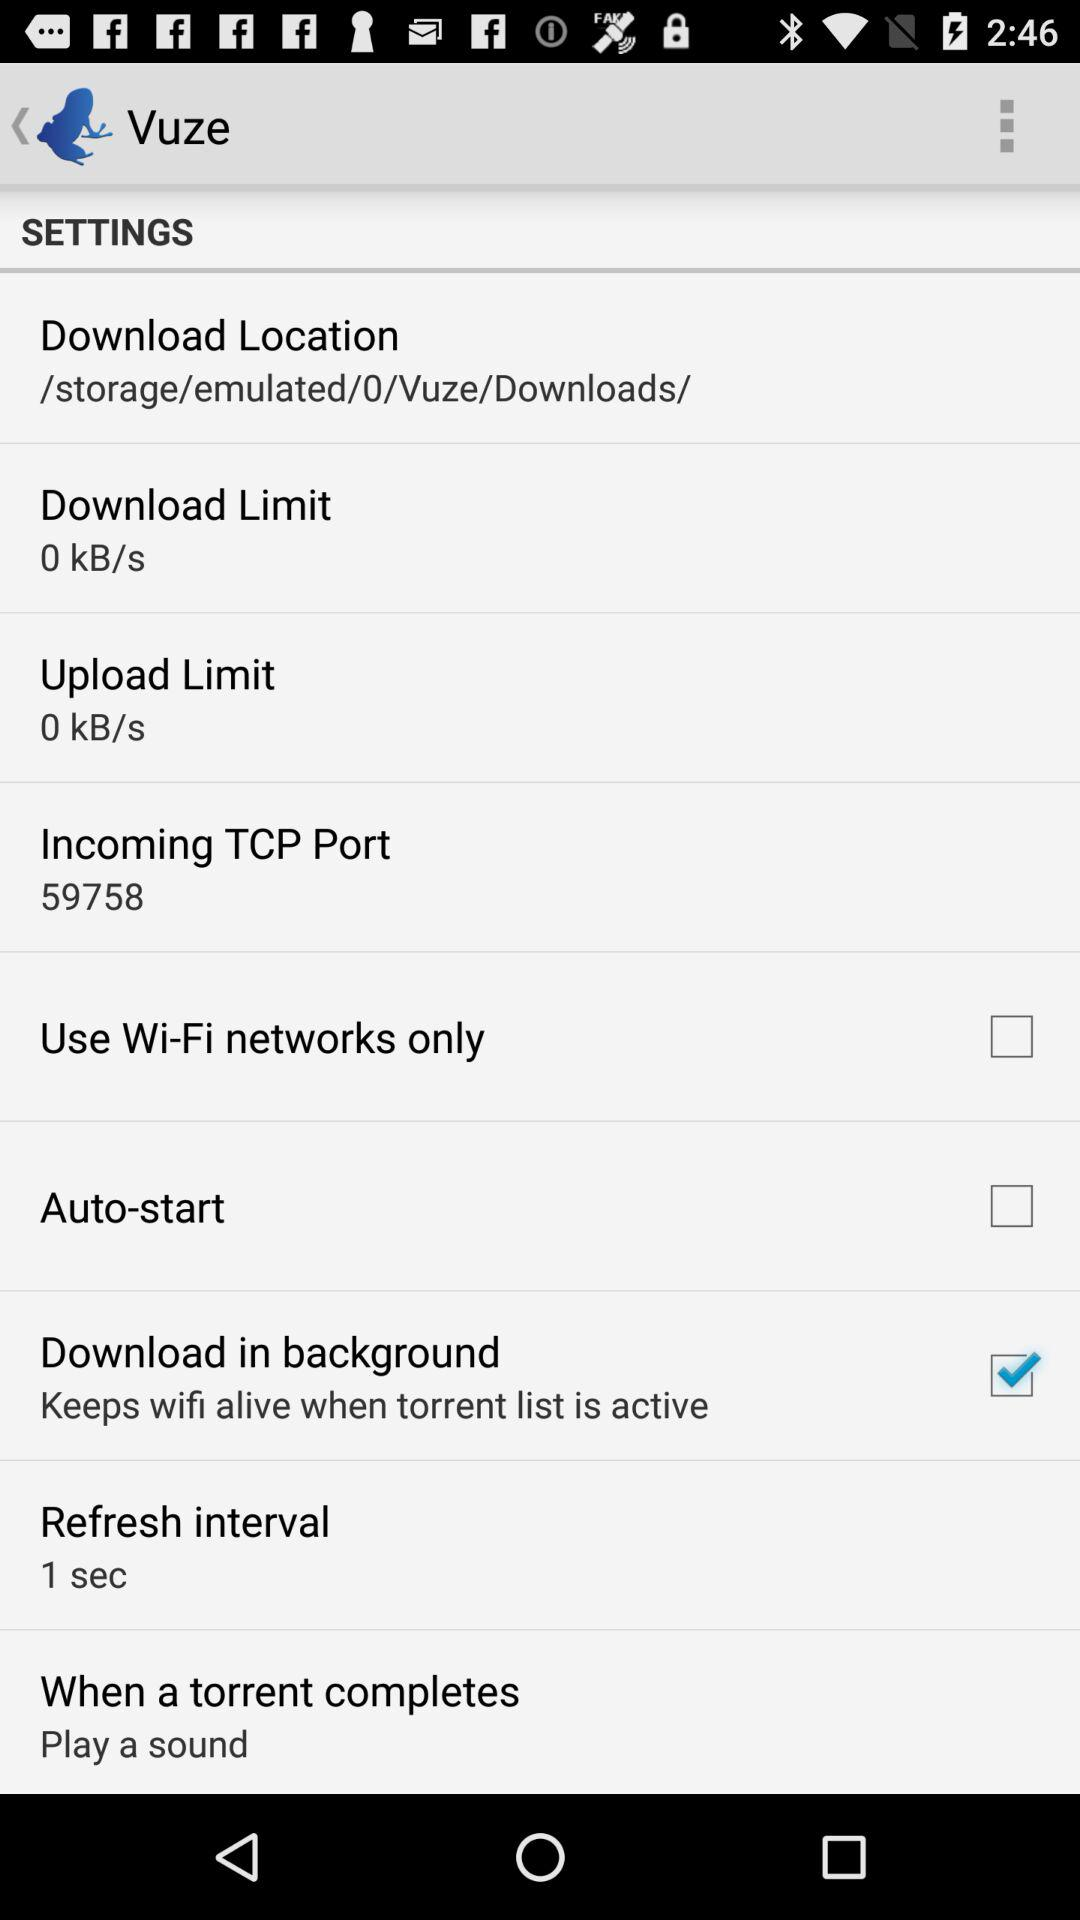What is the status of "Download in background"? The status is "on". 